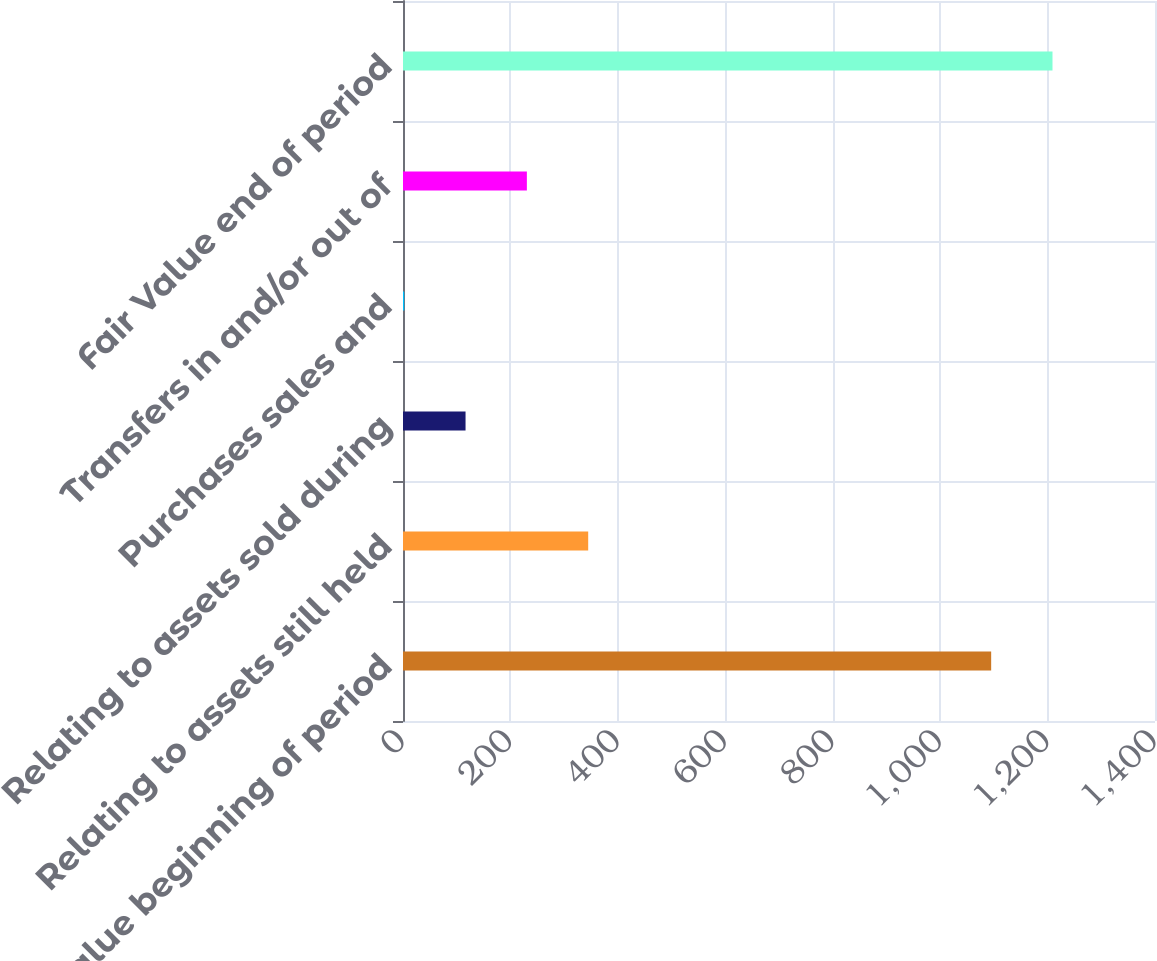<chart> <loc_0><loc_0><loc_500><loc_500><bar_chart><fcel>Fair Value beginning of period<fcel>Relating to assets still held<fcel>Relating to assets sold during<fcel>Purchases sales and<fcel>Transfers in and/or out of<fcel>Fair Value end of period<nl><fcel>1095<fcel>344.78<fcel>116.44<fcel>2.27<fcel>230.61<fcel>1209.17<nl></chart> 